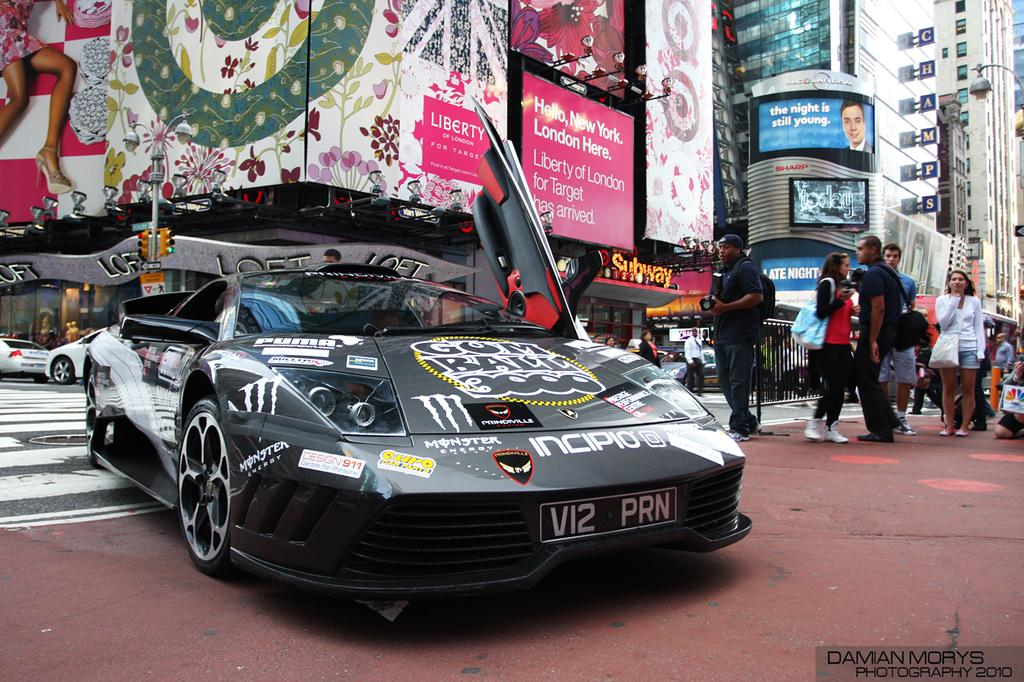What can be seen on the road in the image? There are vehicles and people on the road in the image. What is visible in the background of the image? There are buildings visible in the background of the image. What is attached to the buildings in the image? Banners are present on the buildings. Where are the patches of pear trees located in the image? There are no patches of pear trees present in the image. What type of fruit can be seen growing on the oranges in the image? There are no oranges present in the image. 